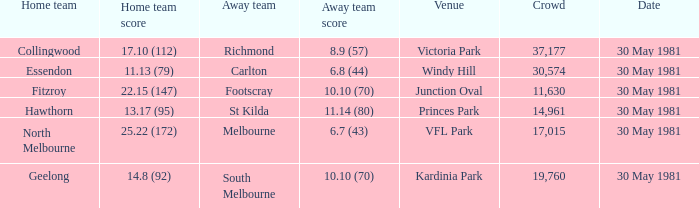What is the home venue of essendon with a crowd larger than 19,760? Windy Hill. 